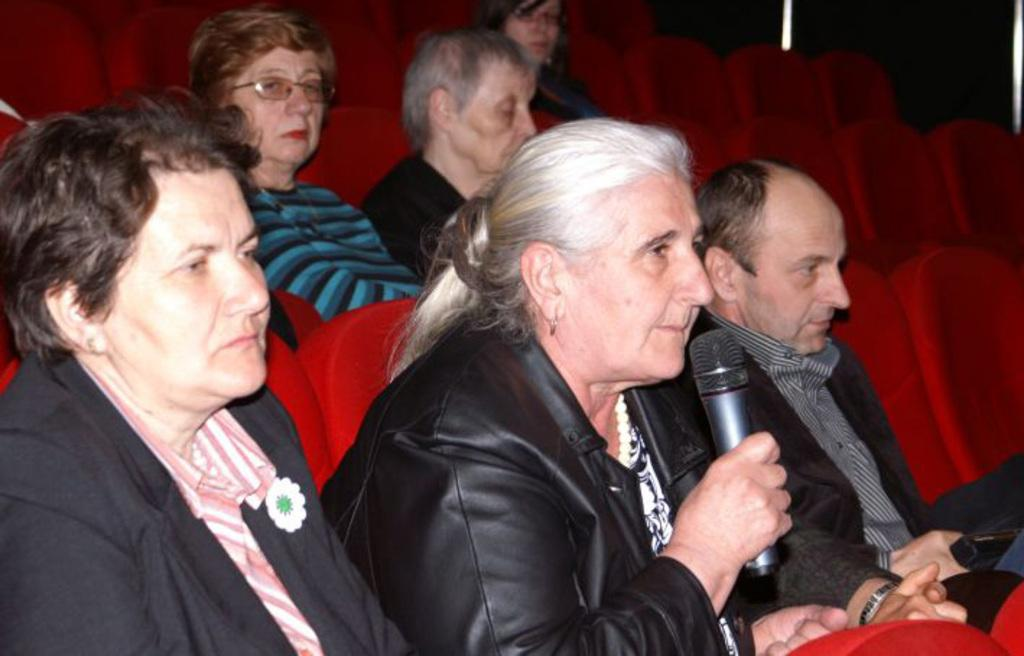What are the people in the image doing? The people in the image are sitting on a car. Can you describe any specific actions or objects being held by the people? One person is holding a microphone in the image. What type of vessel is being used for painting in the image? There is no vessel or painting activity present in the image. 